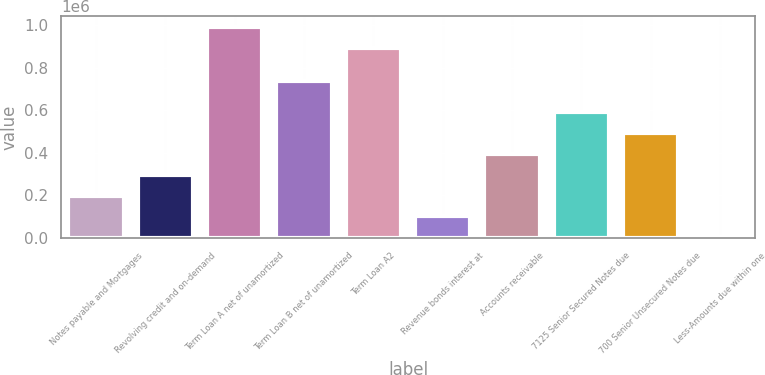Convert chart to OTSL. <chart><loc_0><loc_0><loc_500><loc_500><bar_chart><fcel>Notes payable and Mortgages<fcel>Revolving credit and on-demand<fcel>Term Loan A net of unamortized<fcel>Term Loan B net of unamortized<fcel>Term Loan A2<fcel>Revenue bonds interest at<fcel>Accounts receivable<fcel>7125 Senior Secured Notes due<fcel>700 Senior Unsecured Notes due<fcel>Less-Amounts due within one<nl><fcel>198759<fcel>296844<fcel>992460<fcel>737176<fcel>894375<fcel>100674<fcel>394929<fcel>591098<fcel>493014<fcel>2589<nl></chart> 